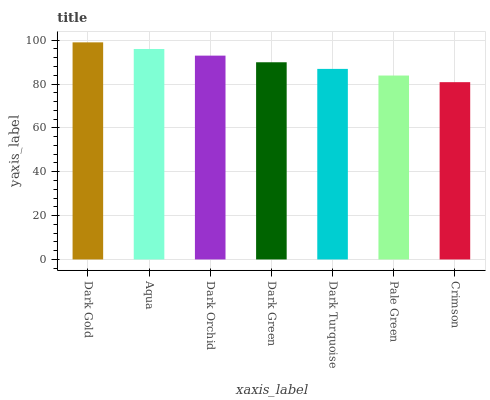Is Crimson the minimum?
Answer yes or no. Yes. Is Dark Gold the maximum?
Answer yes or no. Yes. Is Aqua the minimum?
Answer yes or no. No. Is Aqua the maximum?
Answer yes or no. No. Is Dark Gold greater than Aqua?
Answer yes or no. Yes. Is Aqua less than Dark Gold?
Answer yes or no. Yes. Is Aqua greater than Dark Gold?
Answer yes or no. No. Is Dark Gold less than Aqua?
Answer yes or no. No. Is Dark Green the high median?
Answer yes or no. Yes. Is Dark Green the low median?
Answer yes or no. Yes. Is Aqua the high median?
Answer yes or no. No. Is Pale Green the low median?
Answer yes or no. No. 